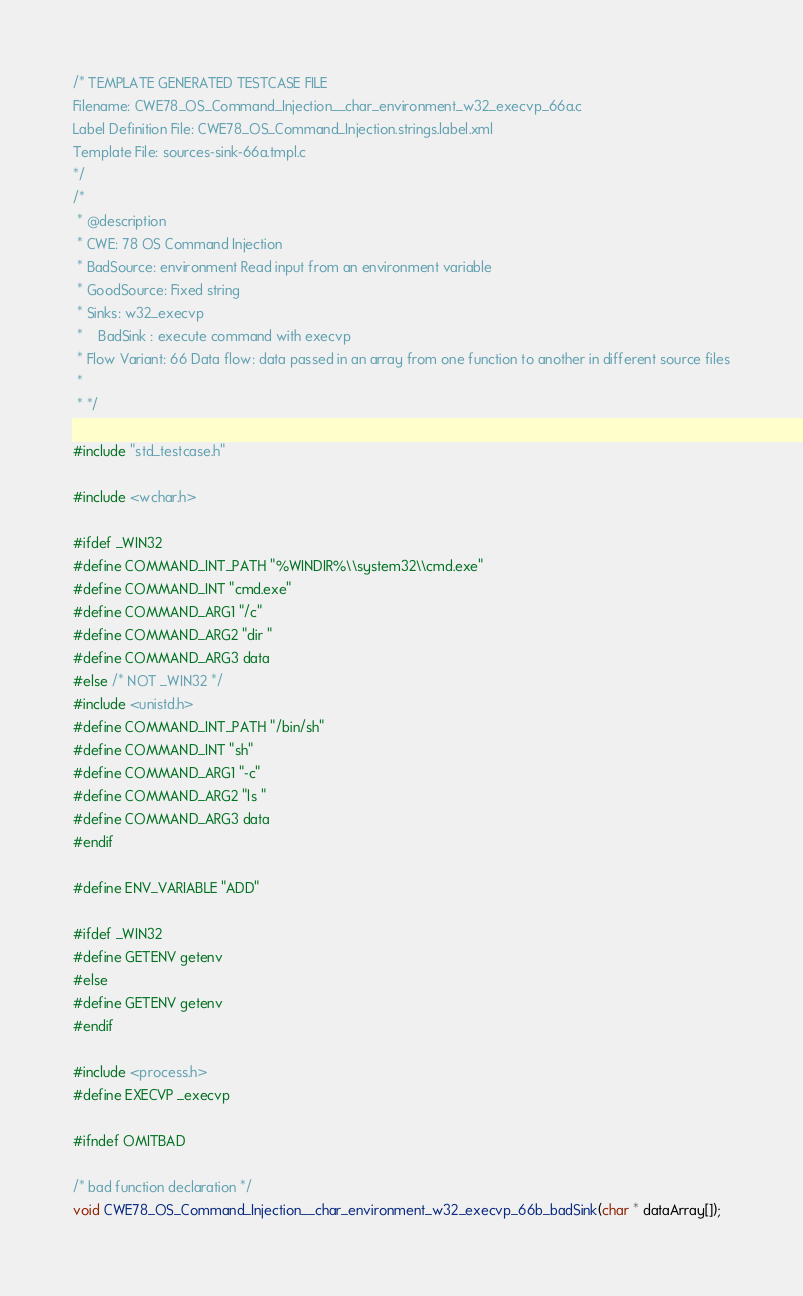<code> <loc_0><loc_0><loc_500><loc_500><_C_>/* TEMPLATE GENERATED TESTCASE FILE
Filename: CWE78_OS_Command_Injection__char_environment_w32_execvp_66a.c
Label Definition File: CWE78_OS_Command_Injection.strings.label.xml
Template File: sources-sink-66a.tmpl.c
*/
/*
 * @description
 * CWE: 78 OS Command Injection
 * BadSource: environment Read input from an environment variable
 * GoodSource: Fixed string
 * Sinks: w32_execvp
 *    BadSink : execute command with execvp
 * Flow Variant: 66 Data flow: data passed in an array from one function to another in different source files
 *
 * */

#include "std_testcase.h"

#include <wchar.h>

#ifdef _WIN32
#define COMMAND_INT_PATH "%WINDIR%\\system32\\cmd.exe"
#define COMMAND_INT "cmd.exe"
#define COMMAND_ARG1 "/c"
#define COMMAND_ARG2 "dir "
#define COMMAND_ARG3 data
#else /* NOT _WIN32 */
#include <unistd.h>
#define COMMAND_INT_PATH "/bin/sh"
#define COMMAND_INT "sh"
#define COMMAND_ARG1 "-c"
#define COMMAND_ARG2 "ls "
#define COMMAND_ARG3 data
#endif

#define ENV_VARIABLE "ADD"

#ifdef _WIN32
#define GETENV getenv
#else
#define GETENV getenv
#endif

#include <process.h>
#define EXECVP _execvp

#ifndef OMITBAD

/* bad function declaration */
void CWE78_OS_Command_Injection__char_environment_w32_execvp_66b_badSink(char * dataArray[]);
</code> 